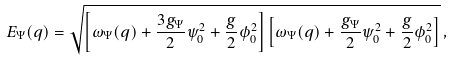<formula> <loc_0><loc_0><loc_500><loc_500>E _ { \Psi } ( { q } ) = \sqrt { \left [ \omega _ { \Psi } ( { q } ) + \frac { 3 g _ { \Psi } } { 2 } \psi _ { 0 } ^ { 2 } + \frac { g } { 2 } \phi _ { 0 } ^ { 2 } \right ] \left [ \omega _ { \Psi } ( { q } ) + \frac { g _ { \Psi } } { 2 } \psi _ { 0 } ^ { 2 } + \frac { g } { 2 } \phi _ { 0 } ^ { 2 } \right ] } \, ,</formula> 